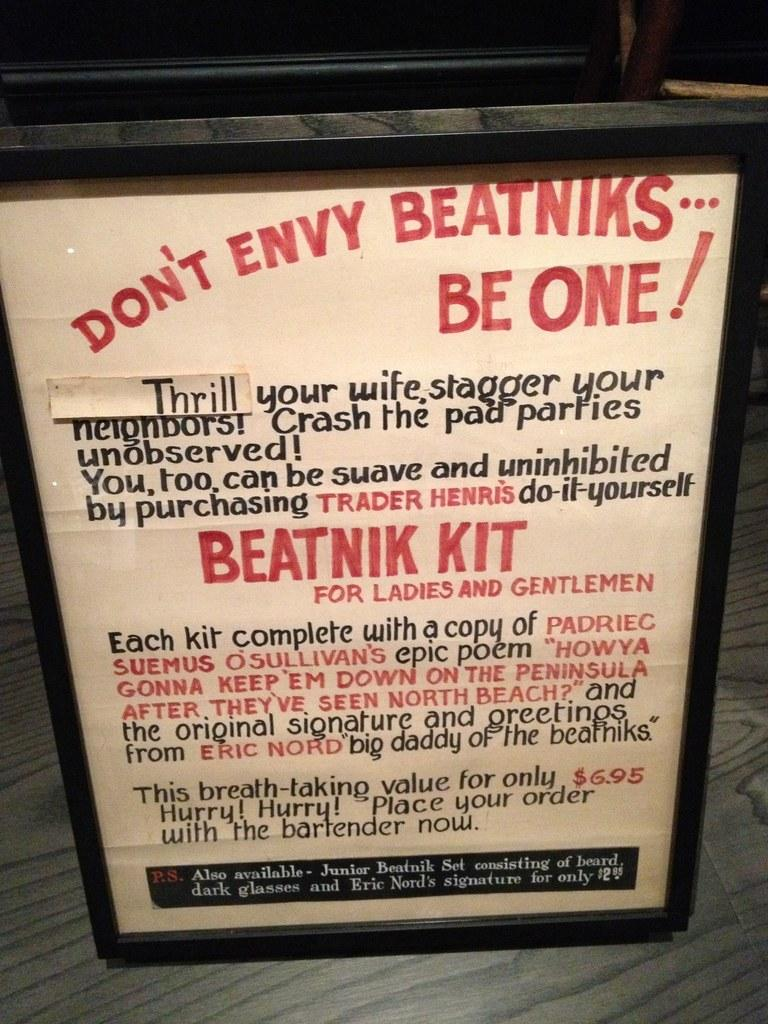<image>
Give a short and clear explanation of the subsequent image. A large poster that says Don't Envy Beatniks...Be One!!! 